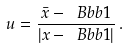<formula> <loc_0><loc_0><loc_500><loc_500>u = \frac { { \bar { x } } - { \ B b b 1 } } { | { x } - { \ B b b 1 } | } \, .</formula> 